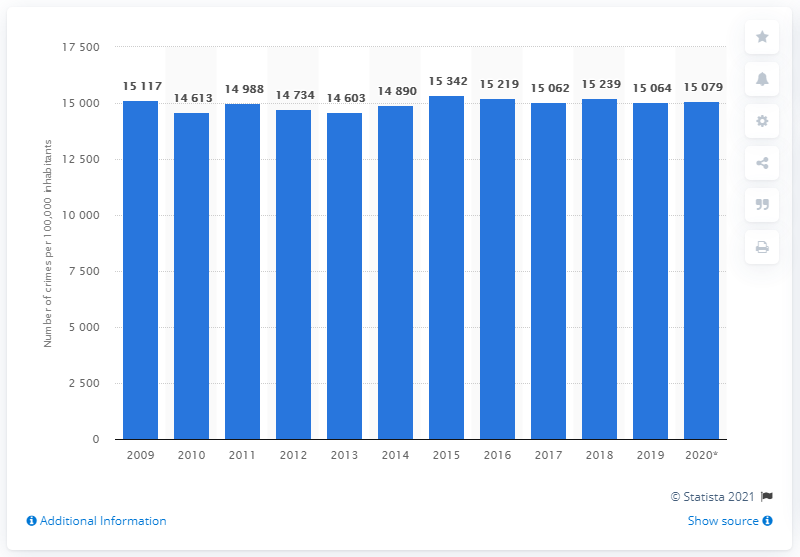In what year was Sweden's highest crime rate?
 2015 